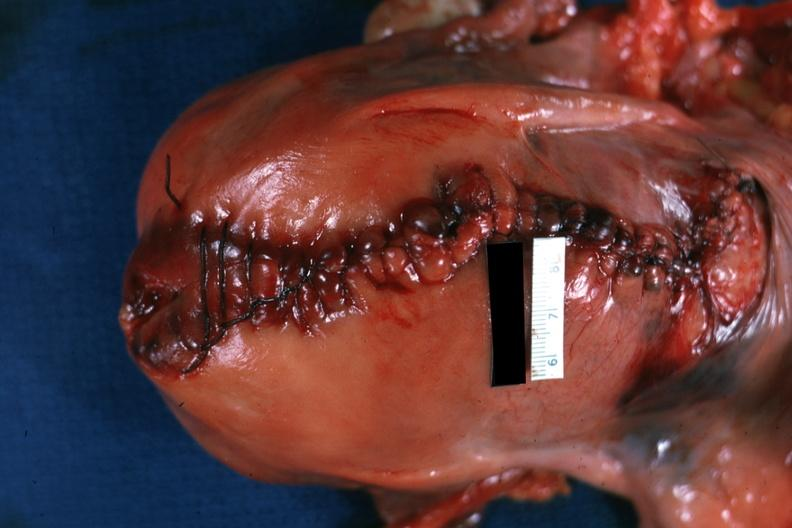does hematoma show sutured cesarean section incision?
Answer the question using a single word or phrase. No 